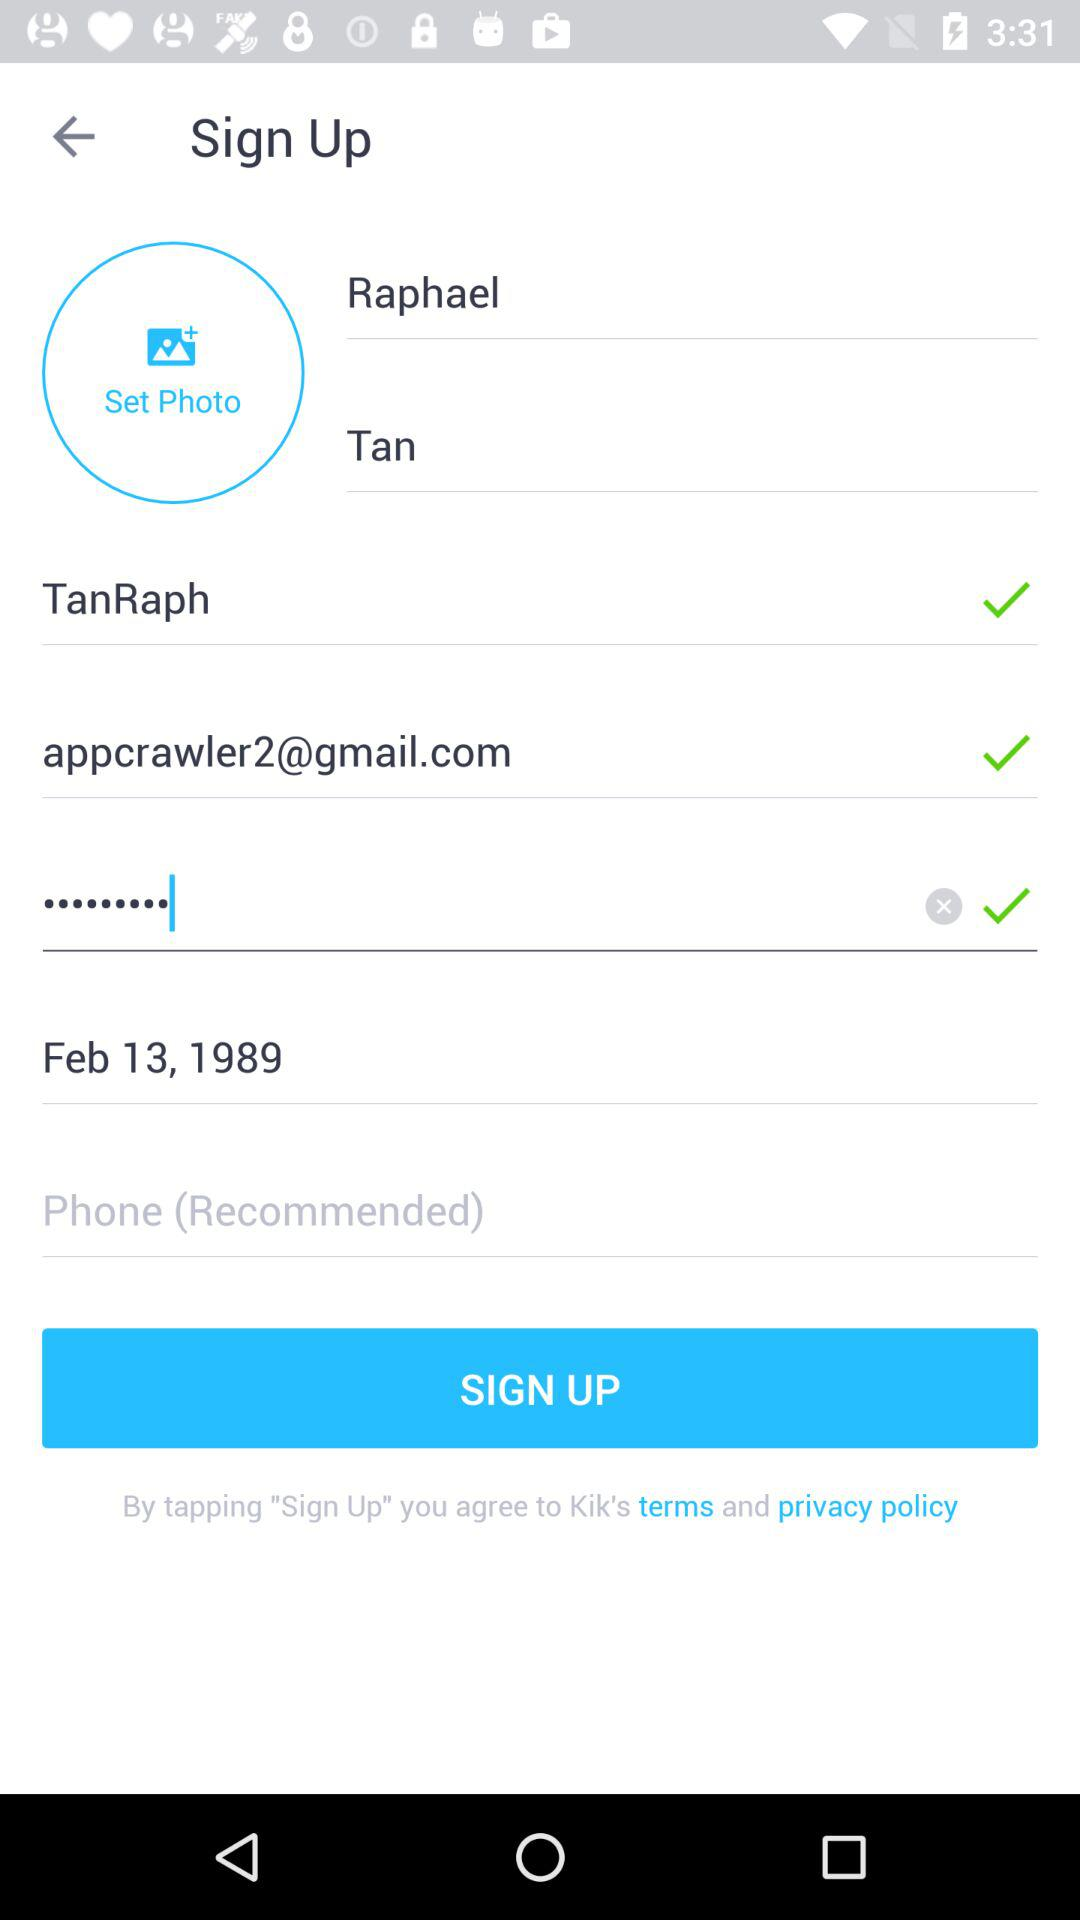What is the Gmail address? The Gmail address is appcrawler2@gmail.com. 